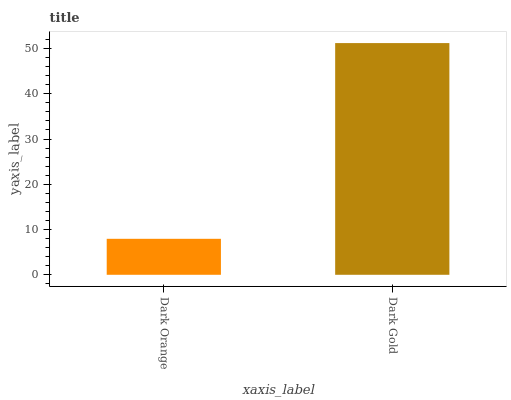Is Dark Orange the minimum?
Answer yes or no. Yes. Is Dark Gold the maximum?
Answer yes or no. Yes. Is Dark Gold the minimum?
Answer yes or no. No. Is Dark Gold greater than Dark Orange?
Answer yes or no. Yes. Is Dark Orange less than Dark Gold?
Answer yes or no. Yes. Is Dark Orange greater than Dark Gold?
Answer yes or no. No. Is Dark Gold less than Dark Orange?
Answer yes or no. No. Is Dark Gold the high median?
Answer yes or no. Yes. Is Dark Orange the low median?
Answer yes or no. Yes. Is Dark Orange the high median?
Answer yes or no. No. Is Dark Gold the low median?
Answer yes or no. No. 